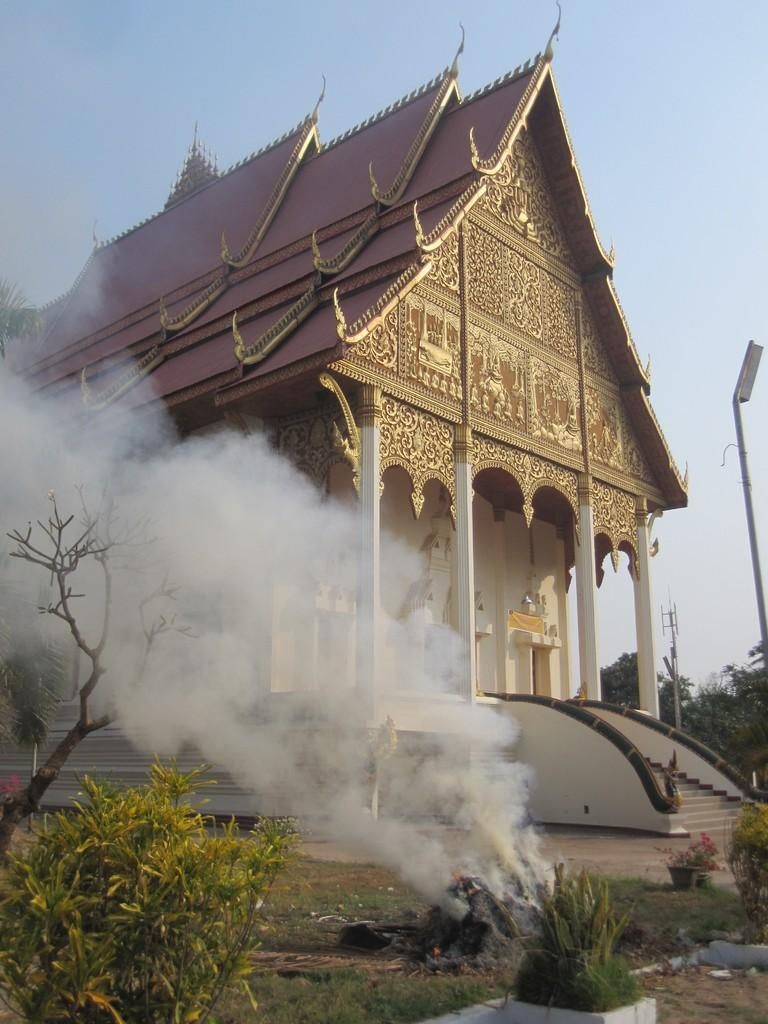What is present at the bottom of the image? There are plants, grass, and smoke visible at the bottom of the image. What can be seen in the background of the image? There is a building, steps, pillars, poles, trees, and the sky visible in the background of the image. What type of muscle can be seen flexing in the image? There is no muscle present in the image. What is the whip used for in the image? There is no whip present in the image. 